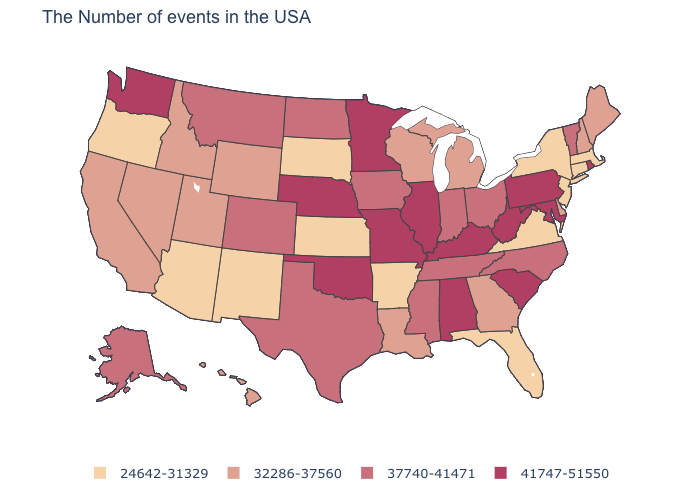Which states have the lowest value in the USA?
Answer briefly. Massachusetts, Connecticut, New York, New Jersey, Virginia, Florida, Arkansas, Kansas, South Dakota, New Mexico, Arizona, Oregon. Does Vermont have the lowest value in the USA?
Quick response, please. No. Is the legend a continuous bar?
Short answer required. No. Among the states that border Vermont , which have the lowest value?
Be succinct. Massachusetts, New York. What is the value of South Dakota?
Quick response, please. 24642-31329. Name the states that have a value in the range 32286-37560?
Quick response, please. Maine, New Hampshire, Delaware, Georgia, Michigan, Wisconsin, Louisiana, Wyoming, Utah, Idaho, Nevada, California, Hawaii. How many symbols are there in the legend?
Write a very short answer. 4. What is the value of Wisconsin?
Short answer required. 32286-37560. Does Arkansas have the highest value in the South?
Write a very short answer. No. Among the states that border West Virginia , which have the highest value?
Be succinct. Maryland, Pennsylvania, Kentucky. What is the lowest value in states that border South Dakota?
Keep it brief. 32286-37560. Among the states that border Iowa , which have the lowest value?
Be succinct. South Dakota. Does North Dakota have the lowest value in the USA?
Give a very brief answer. No. How many symbols are there in the legend?
Answer briefly. 4. What is the value of Michigan?
Give a very brief answer. 32286-37560. 